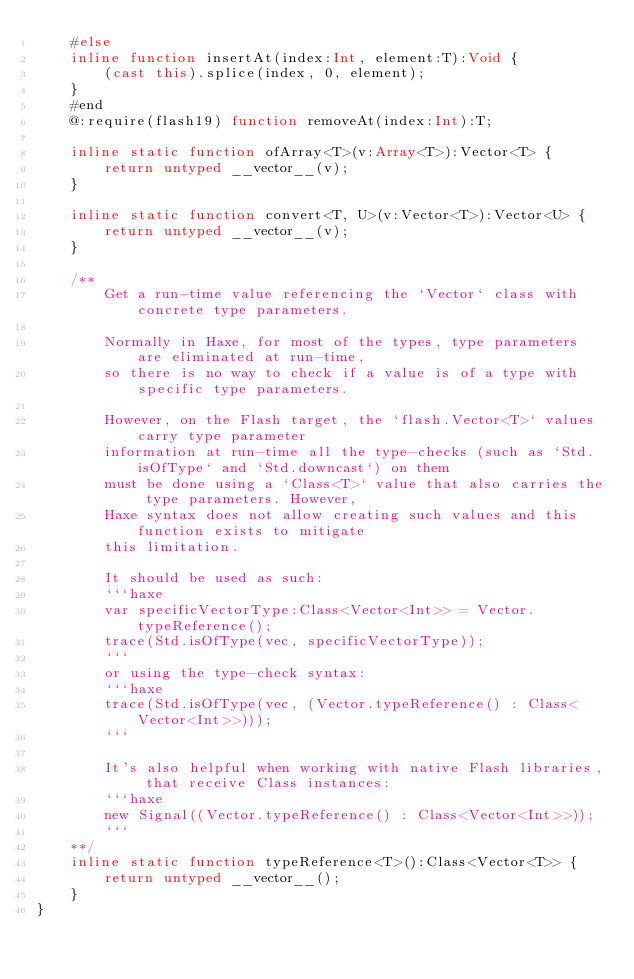Convert code to text. <code><loc_0><loc_0><loc_500><loc_500><_Haxe_>	#else
	inline function insertAt(index:Int, element:T):Void {
		(cast this).splice(index, 0, element);
	}
	#end
	@:require(flash19) function removeAt(index:Int):T;

	inline static function ofArray<T>(v:Array<T>):Vector<T> {
		return untyped __vector__(v);
	}

	inline static function convert<T, U>(v:Vector<T>):Vector<U> {
		return untyped __vector__(v);
	}

	/**
		Get a run-time value referencing the `Vector` class with concrete type parameters.

		Normally in Haxe, for most of the types, type parameters are eliminated at run-time,
		so there is no way to check if a value is of a type with specific type parameters.

		However, on the Flash target, the `flash.Vector<T>` values carry type parameter
		information at run-time all the type-checks (such as `Std.isOfType` and `Std.downcast`) on them
		must be done using a `Class<T>` value that also carries the type parameters. However,
		Haxe syntax does not allow creating such values and this function exists to mitigate
		this limitation.

		It should be used as such:
		```haxe
		var specificVectorType:Class<Vector<Int>> = Vector.typeReference();
		trace(Std.isOfType(vec, specificVectorType));
		```
		or using the type-check syntax:
		```haxe
		trace(Std.isOfType(vec, (Vector.typeReference() : Class<Vector<Int>>)));
		```

		It's also helpful when working with native Flash libraries, that receive Class instances:
		```haxe
		new Signal((Vector.typeReference() : Class<Vector<Int>>));
		```
	**/
	inline static function typeReference<T>():Class<Vector<T>> {
		return untyped __vector__();
	}
}
</code> 